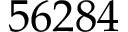Convert formula to latex. <formula><loc_0><loc_0><loc_500><loc_500>5 6 2 8 4</formula> 